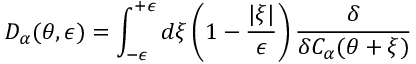Convert formula to latex. <formula><loc_0><loc_0><loc_500><loc_500>D _ { \alpha } ( \theta , \epsilon ) = \int _ { - \epsilon } ^ { + \epsilon } d \xi \left ( 1 - \frac { | \xi | } { \epsilon } \right ) \frac { \delta } { \delta C _ { \alpha } ( \theta + \xi ) }</formula> 